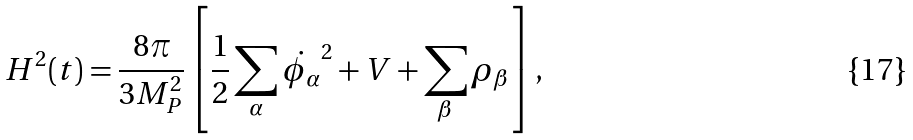Convert formula to latex. <formula><loc_0><loc_0><loc_500><loc_500>H ^ { 2 } ( t ) = \frac { 8 \pi } { 3 M _ { P } ^ { 2 } } \left [ \frac { 1 } { 2 } \sum _ { \alpha } \dot { \phi _ { \alpha } } ^ { 2 } + V + \sum _ { \beta } \rho _ { \beta } \right ] ,</formula> 